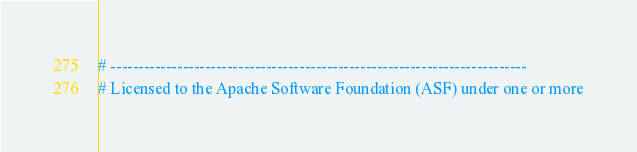<code> <loc_0><loc_0><loc_500><loc_500><_YAML_># ---------------------------------------------------------------------------
# Licensed to the Apache Software Foundation (ASF) under one or more</code> 